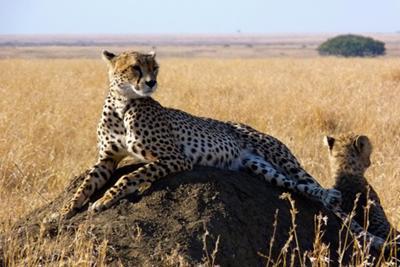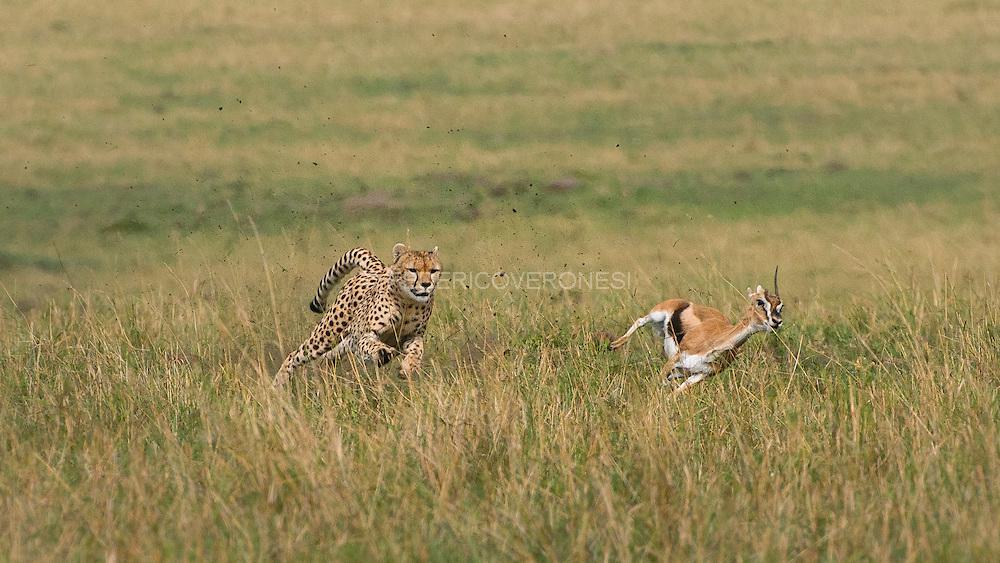The first image is the image on the left, the second image is the image on the right. For the images shown, is this caption "One of the cheetahs is touching its prey." true? Answer yes or no. No. The first image is the image on the left, the second image is the image on the right. For the images displayed, is the sentence "The sky is visible in the background of at least one of the images." factually correct? Answer yes or no. Yes. 